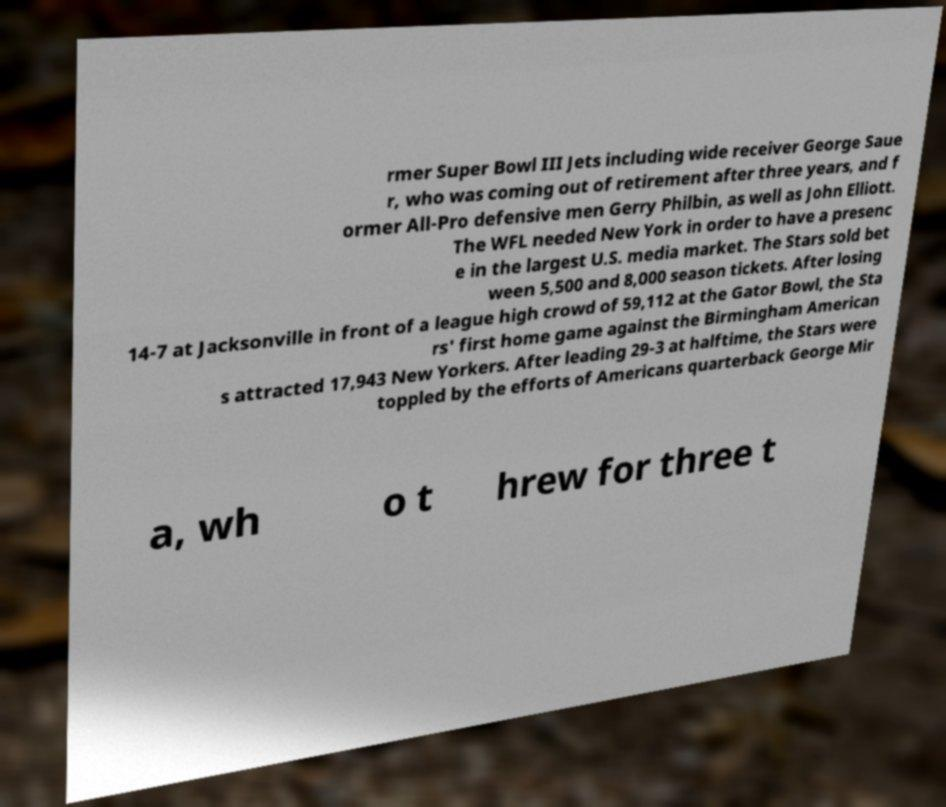Can you accurately transcribe the text from the provided image for me? rmer Super Bowl III Jets including wide receiver George Saue r, who was coming out of retirement after three years, and f ormer All-Pro defensive men Gerry Philbin, as well as John Elliott. The WFL needed New York in order to have a presenc e in the largest U.S. media market. The Stars sold bet ween 5,500 and 8,000 season tickets. After losing 14-7 at Jacksonville in front of a league high crowd of 59,112 at the Gator Bowl, the Sta rs' first home game against the Birmingham American s attracted 17,943 New Yorkers. After leading 29-3 at halftime, the Stars were toppled by the efforts of Americans quarterback George Mir a, wh o t hrew for three t 